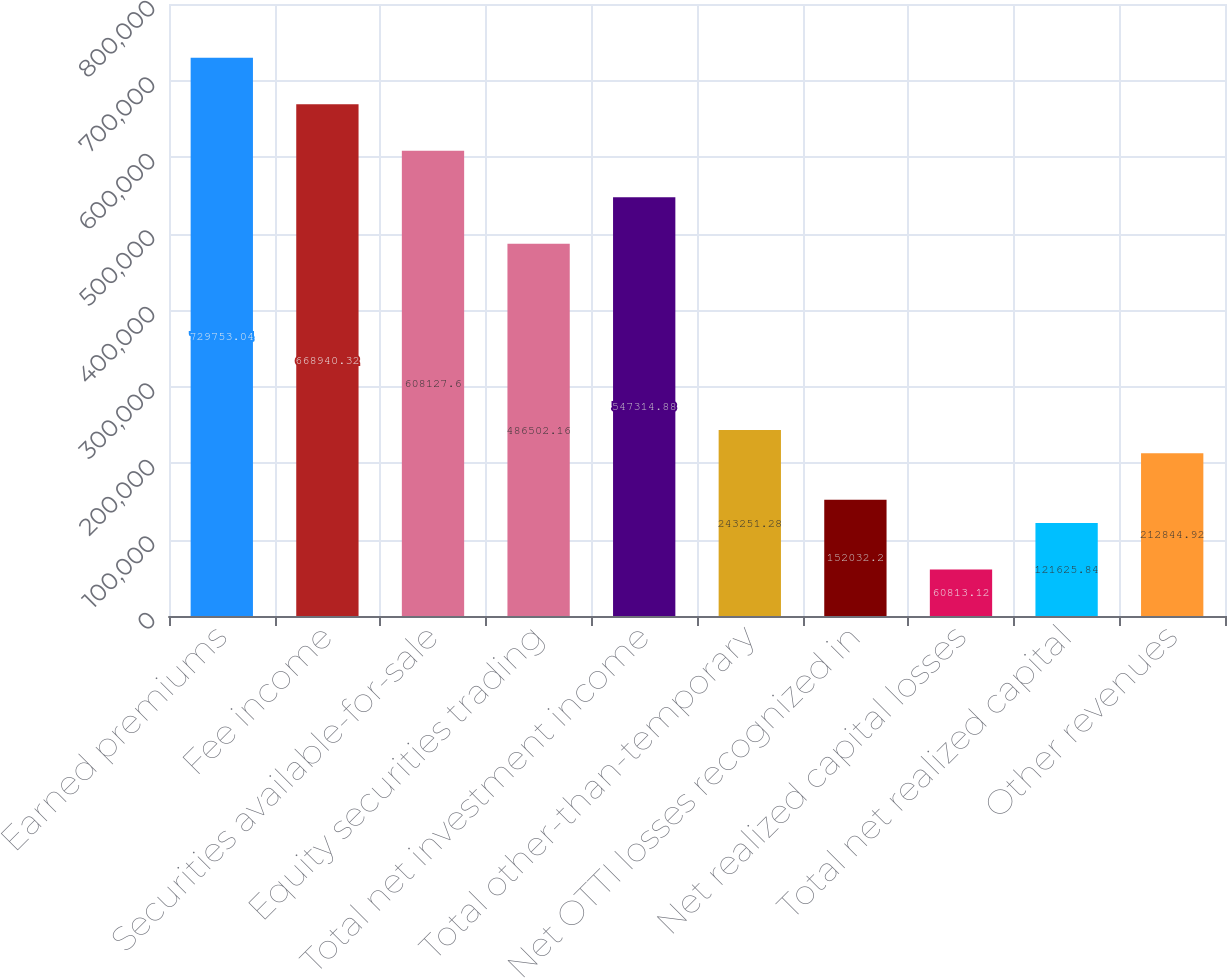<chart> <loc_0><loc_0><loc_500><loc_500><bar_chart><fcel>Earned premiums<fcel>Fee income<fcel>Securities available-for-sale<fcel>Equity securities trading<fcel>Total net investment income<fcel>Total other-than-temporary<fcel>Net OTTI losses recognized in<fcel>Net realized capital losses<fcel>Total net realized capital<fcel>Other revenues<nl><fcel>729753<fcel>668940<fcel>608128<fcel>486502<fcel>547315<fcel>243251<fcel>152032<fcel>60813.1<fcel>121626<fcel>212845<nl></chart> 